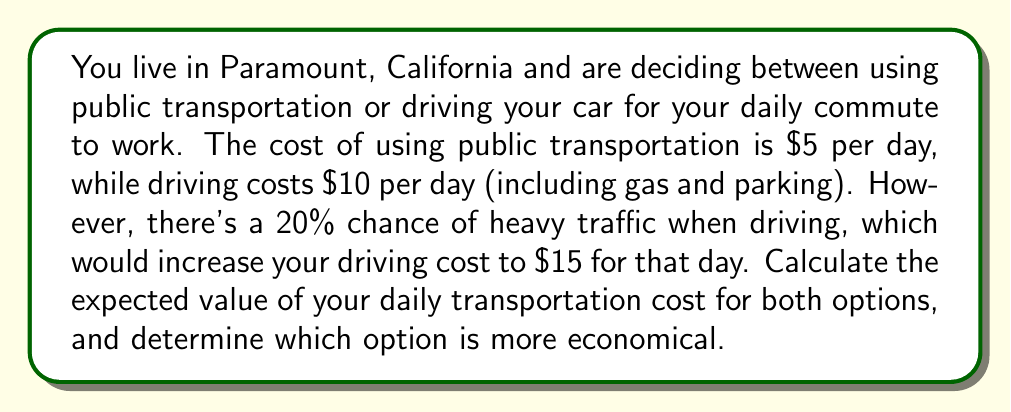Provide a solution to this math problem. To solve this problem, we need to calculate the expected value for both options:

1. Public Transportation:
   The cost is fixed at $5 per day, so the expected value is simply $5.

   $E(\text{Public Transportation}) = $5$

2. Driving:
   We need to consider two scenarios:
   a) Normal traffic (80% probability): Cost = $10
   b) Heavy traffic (20% probability): Cost = $15

   The expected value for driving is calculated using the formula:
   
   $$E(\text{Driving}) = P(\text{Normal}) \cdot \text{Cost}_\text{Normal} + P(\text{Heavy}) \cdot \text{Cost}_\text{Heavy}$$

   Substituting the values:

   $$E(\text{Driving}) = 0.80 \cdot $10 + 0.20 \cdot $15$$
   $$E(\text{Driving}) = $8 + $3 = $11$$

Comparing the two options:
- Public Transportation: $5 per day
- Driving: $11 per day

The difference in expected daily cost is:
$$\text{Difference} = E(\text{Driving}) - E(\text{Public Transportation}) = $11 - $5 = $6$$
Answer: The expected value of using public transportation is $5 per day, while the expected value of driving is $11 per day. Public transportation is more economical, saving an expected $6 per day. 